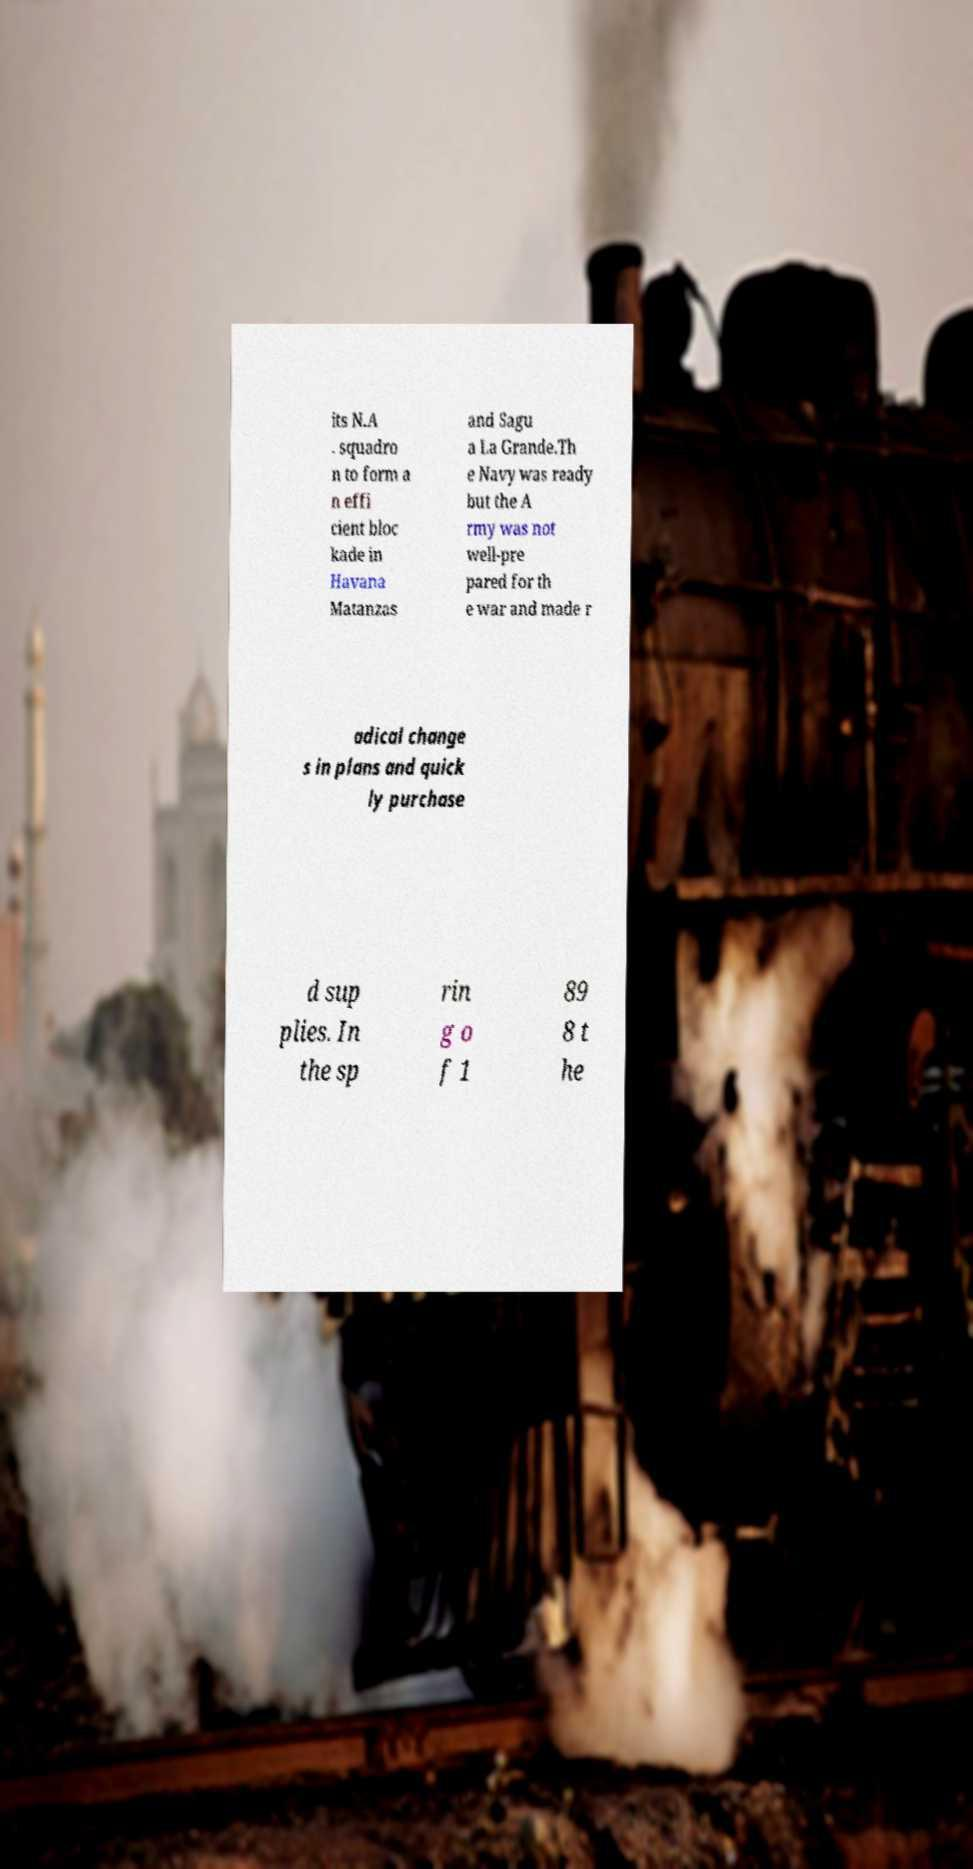Please read and relay the text visible in this image. What does it say? its N.A . squadro n to form a n effi cient bloc kade in Havana Matanzas and Sagu a La Grande.Th e Navy was ready but the A rmy was not well-pre pared for th e war and made r adical change s in plans and quick ly purchase d sup plies. In the sp rin g o f 1 89 8 t he 